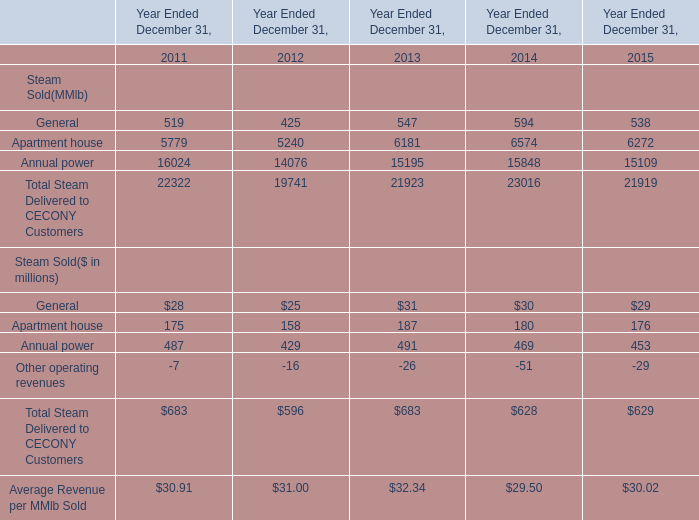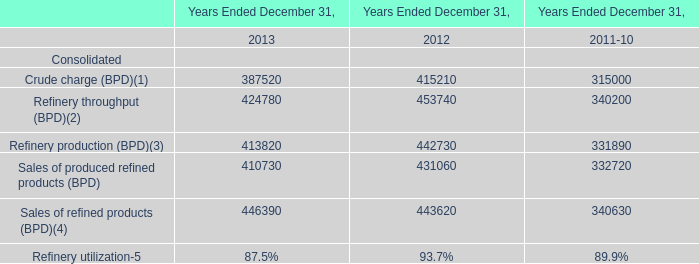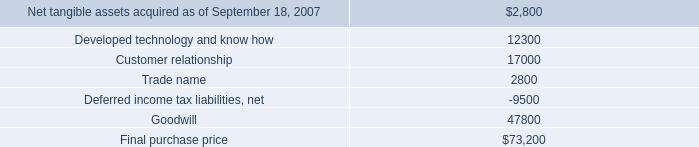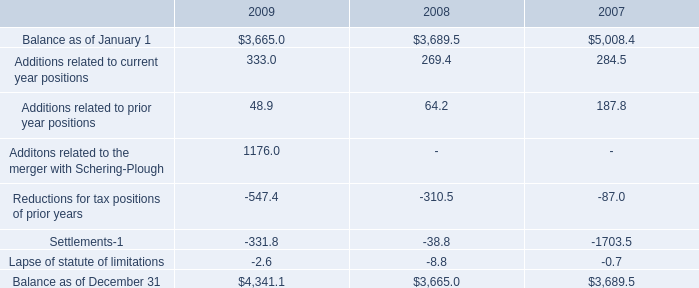What is the sum of Other operating revenues in 2013 and Additions related to prior year positions in 2008? (in million) 
Computations: (-26 + 64.2)
Answer: 38.2. 